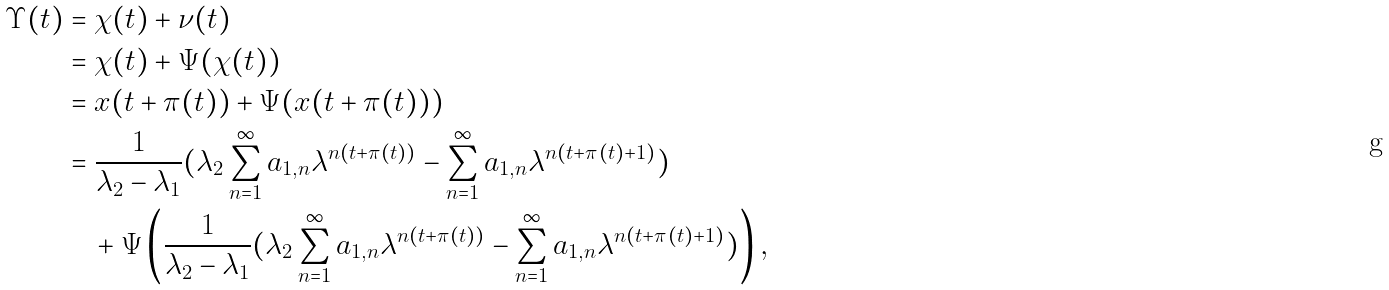<formula> <loc_0><loc_0><loc_500><loc_500>\Upsilon ( t ) & = \chi ( t ) + \nu ( t ) \\ & = \chi ( t ) + \Psi ( \chi ( t ) ) \\ & = x ( t + \pi ( t ) ) + \Psi ( x ( t + \pi ( t ) ) ) \\ & = \frac { 1 } { \lambda _ { 2 } - \lambda _ { 1 } } ( \lambda _ { 2 } \sum ^ { \infty } _ { n = 1 } a _ { 1 , n } \lambda ^ { n ( t + \pi ( t ) ) } - \sum ^ { \infty } _ { n = 1 } a _ { 1 , n } \lambda ^ { n ( t + \pi ( t ) + 1 ) } ) \\ & \quad + \Psi \left ( \frac { 1 } { \lambda _ { 2 } - \lambda _ { 1 } } ( \lambda _ { 2 } \sum ^ { \infty } _ { n = 1 } a _ { 1 , n } \lambda ^ { n ( t + \pi ( t ) ) } - \sum ^ { \infty } _ { n = 1 } a _ { 1 , n } \lambda ^ { n ( t + \pi ( t ) + 1 ) } ) \right ) ,</formula> 